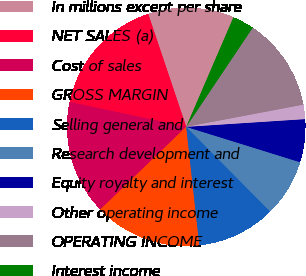Convert chart to OTSL. <chart><loc_0><loc_0><loc_500><loc_500><pie_chart><fcel>In millions except per share<fcel>NET SALES (a)<fcel>Cost of sales<fcel>GROSS MARGIN<fcel>Selling general and<fcel>Research development and<fcel>Equity royalty and interest<fcel>Other operating income<fcel>OPERATING INCOME<fcel>Interest income<nl><fcel>11.65%<fcel>16.5%<fcel>15.53%<fcel>14.56%<fcel>10.68%<fcel>7.77%<fcel>5.83%<fcel>1.95%<fcel>12.62%<fcel>2.92%<nl></chart> 